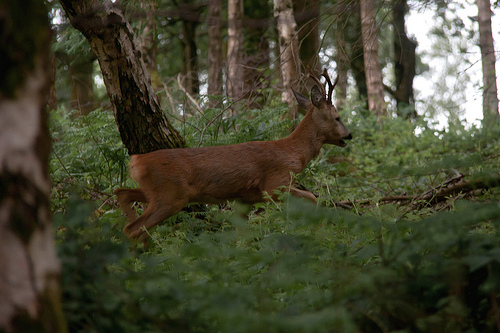<image>
Is there a tree on the deer? No. The tree is not positioned on the deer. They may be near each other, but the tree is not supported by or resting on top of the deer. Where is the deer in relation to the tree? Is it behind the tree? No. The deer is not behind the tree. From this viewpoint, the deer appears to be positioned elsewhere in the scene. Where is the deer in relation to the tree? Is it in front of the tree? No. The deer is not in front of the tree. The spatial positioning shows a different relationship between these objects. 